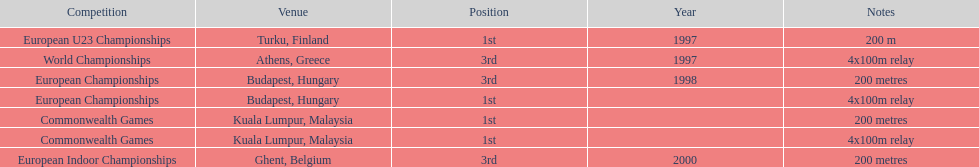List the competitions that have the same relay as world championships from athens, greece. European Championships, Commonwealth Games. 